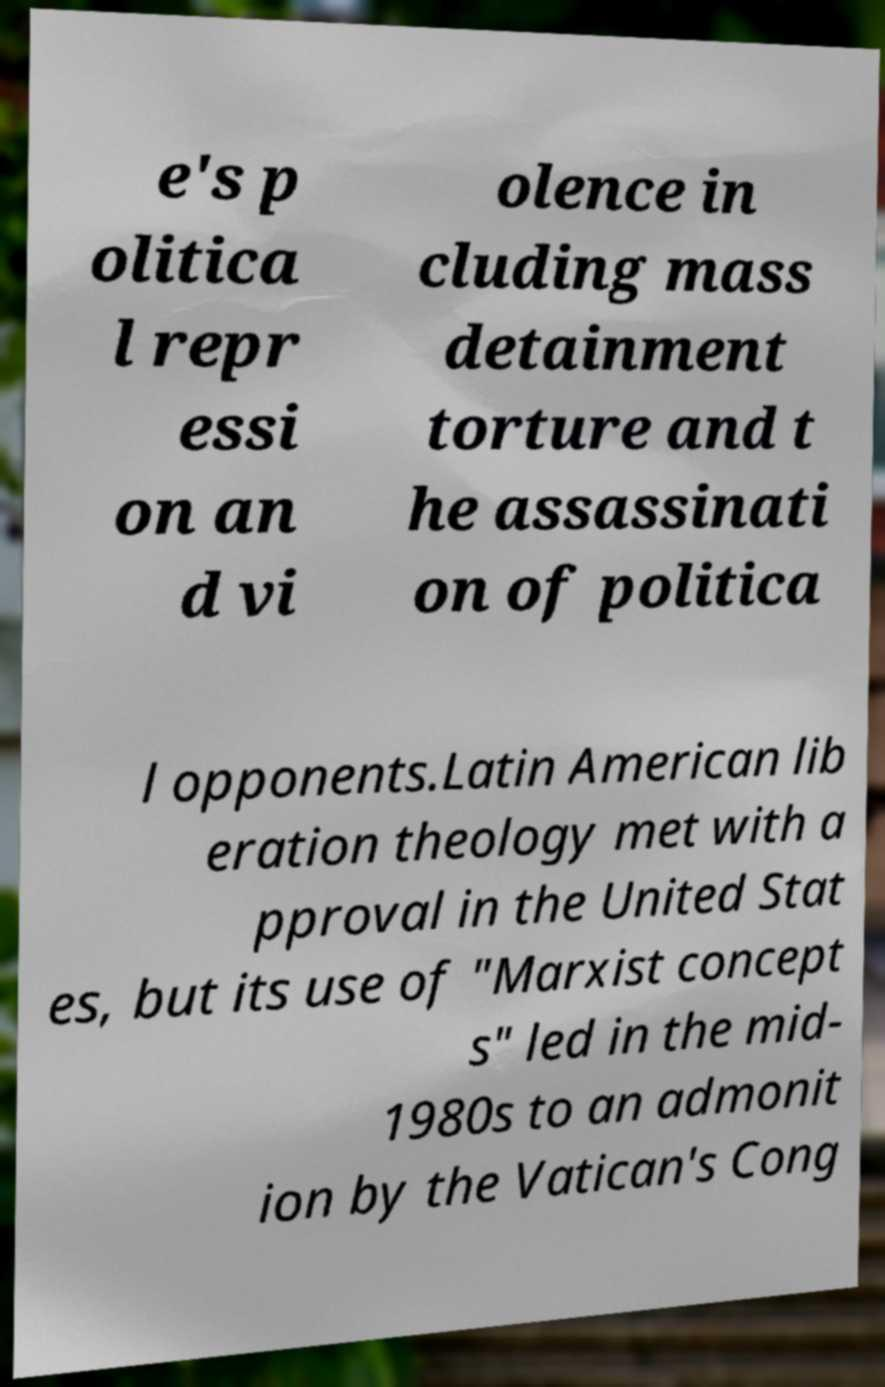There's text embedded in this image that I need extracted. Can you transcribe it verbatim? e's p olitica l repr essi on an d vi olence in cluding mass detainment torture and t he assassinati on of politica l opponents.Latin American lib eration theology met with a pproval in the United Stat es, but its use of "Marxist concept s" led in the mid- 1980s to an admonit ion by the Vatican's Cong 